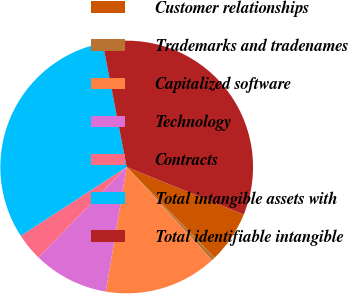<chart> <loc_0><loc_0><loc_500><loc_500><pie_chart><fcel>Customer relationships<fcel>Trademarks and tradenames<fcel>Capitalized software<fcel>Technology<fcel>Contracts<fcel>Total intangible assets with<fcel>Total identifiable intangible<nl><fcel>6.6%<fcel>0.46%<fcel>14.44%<fcel>9.66%<fcel>3.53%<fcel>31.12%<fcel>34.19%<nl></chart> 